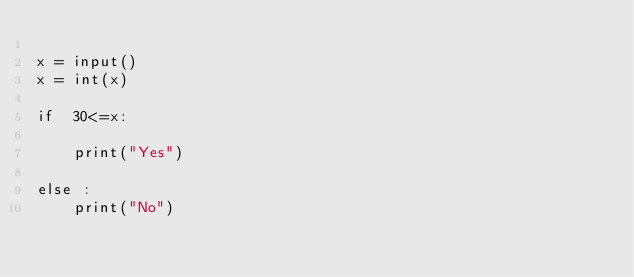Convert code to text. <code><loc_0><loc_0><loc_500><loc_500><_Python_>
x = input()
x = int(x)

if  30<=x:
    
    print("Yes")
    
else :
    print("No")</code> 